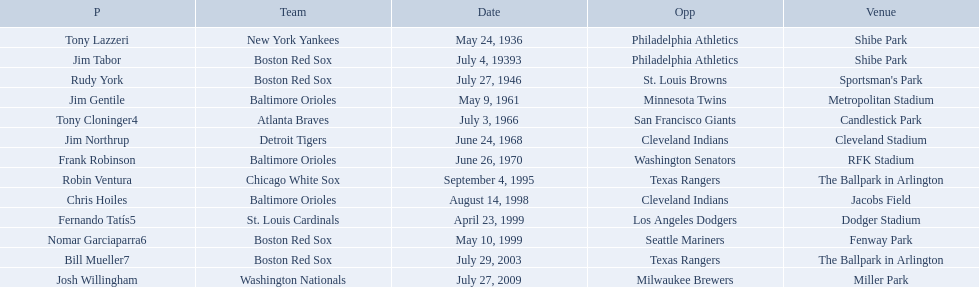Who were all the teams? New York Yankees, Boston Red Sox, Boston Red Sox, Baltimore Orioles, Atlanta Braves, Detroit Tigers, Baltimore Orioles, Chicago White Sox, Baltimore Orioles, St. Louis Cardinals, Boston Red Sox, Boston Red Sox, Washington Nationals. What about opponents? Philadelphia Athletics, Philadelphia Athletics, St. Louis Browns, Minnesota Twins, San Francisco Giants, Cleveland Indians, Washington Senators, Texas Rangers, Cleveland Indians, Los Angeles Dodgers, Seattle Mariners, Texas Rangers, Milwaukee Brewers. And when did they play? May 24, 1936, July 4, 19393, July 27, 1946, May 9, 1961, July 3, 1966, June 24, 1968, June 26, 1970, September 4, 1995, August 14, 1998, April 23, 1999, May 10, 1999, July 29, 2003, July 27, 2009. Which team played the red sox on july 27, 1946	? St. Louis Browns. What are the names of all the players? Tony Lazzeri, Jim Tabor, Rudy York, Jim Gentile, Tony Cloninger4, Jim Northrup, Frank Robinson, Robin Ventura, Chris Hoiles, Fernando Tatís5, Nomar Garciaparra6, Bill Mueller7, Josh Willingham. What are the names of all the teams holding home run records? New York Yankees, Boston Red Sox, Baltimore Orioles, Atlanta Braves, Detroit Tigers, Chicago White Sox, St. Louis Cardinals, Washington Nationals. Which player played for the new york yankees? Tony Lazzeri. What are the dates? May 24, 1936, July 4, 19393, July 27, 1946, May 9, 1961, July 3, 1966, June 24, 1968, June 26, 1970, September 4, 1995, August 14, 1998, April 23, 1999, May 10, 1999, July 29, 2003, July 27, 2009. Which date is in 1936? May 24, 1936. What player is listed for this date? Tony Lazzeri. Who were all of the players? Tony Lazzeri, Jim Tabor, Rudy York, Jim Gentile, Tony Cloninger4, Jim Northrup, Frank Robinson, Robin Ventura, Chris Hoiles, Fernando Tatís5, Nomar Garciaparra6, Bill Mueller7, Josh Willingham. What year was there a player for the yankees? May 24, 1936. What was the name of that 1936 yankees player? Tony Lazzeri. 